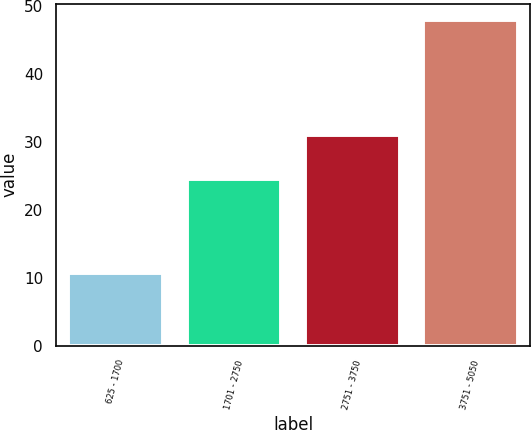Convert chart to OTSL. <chart><loc_0><loc_0><loc_500><loc_500><bar_chart><fcel>625 - 1700<fcel>1701 - 2750<fcel>2751 - 3750<fcel>3751 - 5050<nl><fcel>10.76<fcel>24.56<fcel>31.1<fcel>48<nl></chart> 